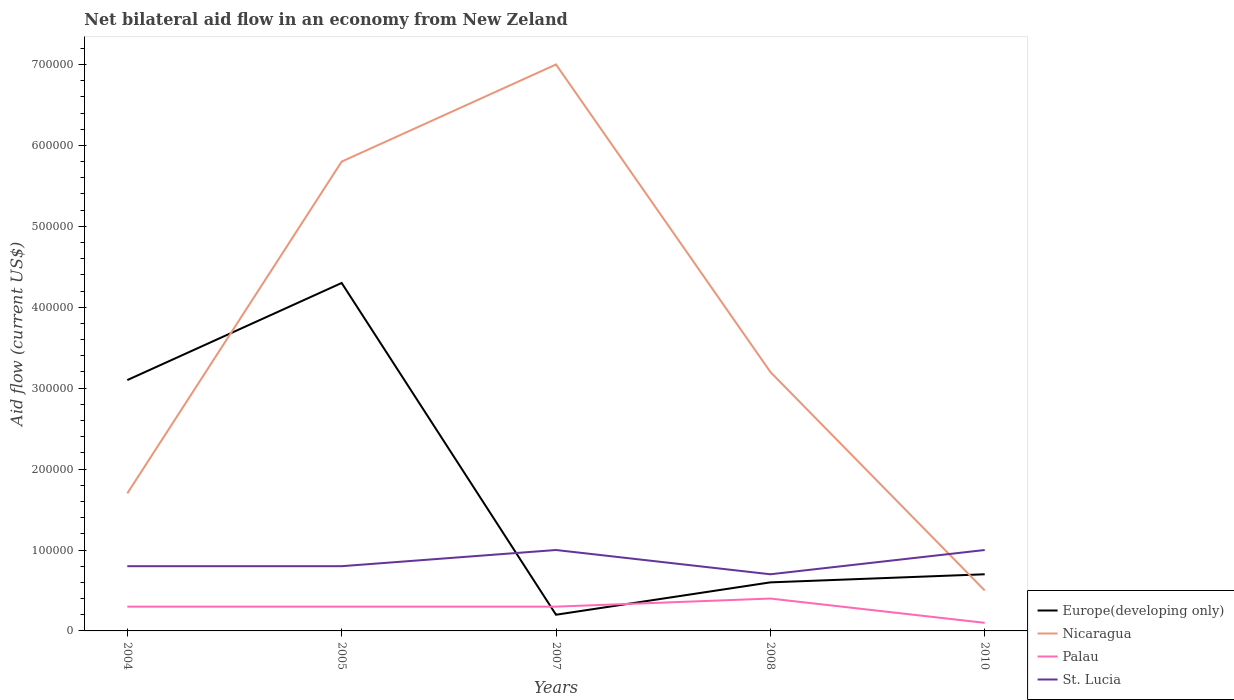How many different coloured lines are there?
Ensure brevity in your answer.  4. Is the number of lines equal to the number of legend labels?
Your answer should be compact. Yes. What is the total net bilateral aid flow in St. Lucia in the graph?
Offer a very short reply. 10000. What is the difference between the highest and the second highest net bilateral aid flow in Europe(developing only)?
Offer a very short reply. 4.10e+05. Is the net bilateral aid flow in Nicaragua strictly greater than the net bilateral aid flow in Europe(developing only) over the years?
Your response must be concise. No. What is the difference between two consecutive major ticks on the Y-axis?
Provide a short and direct response. 1.00e+05. Does the graph contain any zero values?
Your response must be concise. No. How many legend labels are there?
Ensure brevity in your answer.  4. How are the legend labels stacked?
Your answer should be compact. Vertical. What is the title of the graph?
Your response must be concise. Net bilateral aid flow in an economy from New Zeland. Does "Cayman Islands" appear as one of the legend labels in the graph?
Provide a succinct answer. No. What is the label or title of the X-axis?
Ensure brevity in your answer.  Years. What is the label or title of the Y-axis?
Your answer should be compact. Aid flow (current US$). What is the Aid flow (current US$) of Europe(developing only) in 2004?
Ensure brevity in your answer.  3.10e+05. What is the Aid flow (current US$) of Nicaragua in 2004?
Offer a terse response. 1.70e+05. What is the Aid flow (current US$) in Palau in 2004?
Offer a very short reply. 3.00e+04. What is the Aid flow (current US$) in Nicaragua in 2005?
Your answer should be compact. 5.80e+05. What is the Aid flow (current US$) of Europe(developing only) in 2007?
Your answer should be compact. 2.00e+04. What is the Aid flow (current US$) of Nicaragua in 2007?
Ensure brevity in your answer.  7.00e+05. What is the Aid flow (current US$) of Europe(developing only) in 2008?
Your answer should be very brief. 6.00e+04. What is the Aid flow (current US$) of St. Lucia in 2008?
Make the answer very short. 7.00e+04. What is the Aid flow (current US$) of St. Lucia in 2010?
Provide a short and direct response. 1.00e+05. Across all years, what is the maximum Aid flow (current US$) of Europe(developing only)?
Your answer should be very brief. 4.30e+05. Across all years, what is the maximum Aid flow (current US$) in St. Lucia?
Ensure brevity in your answer.  1.00e+05. Across all years, what is the minimum Aid flow (current US$) of Nicaragua?
Offer a very short reply. 5.00e+04. What is the total Aid flow (current US$) of Europe(developing only) in the graph?
Your answer should be compact. 8.90e+05. What is the total Aid flow (current US$) in Nicaragua in the graph?
Offer a terse response. 1.82e+06. What is the total Aid flow (current US$) of Palau in the graph?
Keep it short and to the point. 1.40e+05. What is the difference between the Aid flow (current US$) of Nicaragua in 2004 and that in 2005?
Provide a short and direct response. -4.10e+05. What is the difference between the Aid flow (current US$) of Palau in 2004 and that in 2005?
Offer a terse response. 0. What is the difference between the Aid flow (current US$) of Europe(developing only) in 2004 and that in 2007?
Your answer should be very brief. 2.90e+05. What is the difference between the Aid flow (current US$) of Nicaragua in 2004 and that in 2007?
Ensure brevity in your answer.  -5.30e+05. What is the difference between the Aid flow (current US$) in Palau in 2004 and that in 2008?
Keep it short and to the point. -10000. What is the difference between the Aid flow (current US$) in St. Lucia in 2004 and that in 2008?
Make the answer very short. 10000. What is the difference between the Aid flow (current US$) of Nicaragua in 2004 and that in 2010?
Provide a succinct answer. 1.20e+05. What is the difference between the Aid flow (current US$) of Palau in 2004 and that in 2010?
Your answer should be compact. 2.00e+04. What is the difference between the Aid flow (current US$) in St. Lucia in 2004 and that in 2010?
Provide a succinct answer. -2.00e+04. What is the difference between the Aid flow (current US$) of Europe(developing only) in 2005 and that in 2007?
Make the answer very short. 4.10e+05. What is the difference between the Aid flow (current US$) in Nicaragua in 2005 and that in 2007?
Make the answer very short. -1.20e+05. What is the difference between the Aid flow (current US$) in Palau in 2005 and that in 2007?
Offer a terse response. 0. What is the difference between the Aid flow (current US$) in St. Lucia in 2005 and that in 2007?
Provide a succinct answer. -2.00e+04. What is the difference between the Aid flow (current US$) of Europe(developing only) in 2005 and that in 2008?
Your answer should be very brief. 3.70e+05. What is the difference between the Aid flow (current US$) of Nicaragua in 2005 and that in 2008?
Keep it short and to the point. 2.60e+05. What is the difference between the Aid flow (current US$) in Palau in 2005 and that in 2008?
Your answer should be very brief. -10000. What is the difference between the Aid flow (current US$) in St. Lucia in 2005 and that in 2008?
Provide a short and direct response. 10000. What is the difference between the Aid flow (current US$) in Europe(developing only) in 2005 and that in 2010?
Ensure brevity in your answer.  3.60e+05. What is the difference between the Aid flow (current US$) of Nicaragua in 2005 and that in 2010?
Your answer should be compact. 5.30e+05. What is the difference between the Aid flow (current US$) in Nicaragua in 2007 and that in 2008?
Keep it short and to the point. 3.80e+05. What is the difference between the Aid flow (current US$) of St. Lucia in 2007 and that in 2008?
Ensure brevity in your answer.  3.00e+04. What is the difference between the Aid flow (current US$) in Europe(developing only) in 2007 and that in 2010?
Ensure brevity in your answer.  -5.00e+04. What is the difference between the Aid flow (current US$) in Nicaragua in 2007 and that in 2010?
Your response must be concise. 6.50e+05. What is the difference between the Aid flow (current US$) in Europe(developing only) in 2008 and that in 2010?
Your response must be concise. -10000. What is the difference between the Aid flow (current US$) of Palau in 2008 and that in 2010?
Your answer should be very brief. 3.00e+04. What is the difference between the Aid flow (current US$) of Europe(developing only) in 2004 and the Aid flow (current US$) of Palau in 2005?
Keep it short and to the point. 2.80e+05. What is the difference between the Aid flow (current US$) in Europe(developing only) in 2004 and the Aid flow (current US$) in St. Lucia in 2005?
Offer a terse response. 2.30e+05. What is the difference between the Aid flow (current US$) of Nicaragua in 2004 and the Aid flow (current US$) of Palau in 2005?
Your answer should be compact. 1.40e+05. What is the difference between the Aid flow (current US$) in Nicaragua in 2004 and the Aid flow (current US$) in St. Lucia in 2005?
Offer a very short reply. 9.00e+04. What is the difference between the Aid flow (current US$) in Palau in 2004 and the Aid flow (current US$) in St. Lucia in 2005?
Provide a short and direct response. -5.00e+04. What is the difference between the Aid flow (current US$) in Europe(developing only) in 2004 and the Aid flow (current US$) in Nicaragua in 2007?
Give a very brief answer. -3.90e+05. What is the difference between the Aid flow (current US$) of Europe(developing only) in 2004 and the Aid flow (current US$) of Palau in 2007?
Give a very brief answer. 2.80e+05. What is the difference between the Aid flow (current US$) in Europe(developing only) in 2004 and the Aid flow (current US$) in St. Lucia in 2007?
Your response must be concise. 2.10e+05. What is the difference between the Aid flow (current US$) in Nicaragua in 2004 and the Aid flow (current US$) in Palau in 2007?
Your response must be concise. 1.40e+05. What is the difference between the Aid flow (current US$) in Nicaragua in 2004 and the Aid flow (current US$) in St. Lucia in 2007?
Offer a terse response. 7.00e+04. What is the difference between the Aid flow (current US$) in Europe(developing only) in 2004 and the Aid flow (current US$) in Palau in 2008?
Give a very brief answer. 2.70e+05. What is the difference between the Aid flow (current US$) in Nicaragua in 2004 and the Aid flow (current US$) in Palau in 2008?
Provide a succinct answer. 1.30e+05. What is the difference between the Aid flow (current US$) in Nicaragua in 2004 and the Aid flow (current US$) in St. Lucia in 2008?
Provide a short and direct response. 1.00e+05. What is the difference between the Aid flow (current US$) in Europe(developing only) in 2004 and the Aid flow (current US$) in Palau in 2010?
Your response must be concise. 3.00e+05. What is the difference between the Aid flow (current US$) in Nicaragua in 2004 and the Aid flow (current US$) in Palau in 2010?
Give a very brief answer. 1.60e+05. What is the difference between the Aid flow (current US$) of Palau in 2004 and the Aid flow (current US$) of St. Lucia in 2010?
Offer a very short reply. -7.00e+04. What is the difference between the Aid flow (current US$) in Europe(developing only) in 2005 and the Aid flow (current US$) in Nicaragua in 2007?
Provide a succinct answer. -2.70e+05. What is the difference between the Aid flow (current US$) of Europe(developing only) in 2005 and the Aid flow (current US$) of Palau in 2007?
Provide a succinct answer. 4.00e+05. What is the difference between the Aid flow (current US$) in Europe(developing only) in 2005 and the Aid flow (current US$) in St. Lucia in 2007?
Provide a short and direct response. 3.30e+05. What is the difference between the Aid flow (current US$) in Nicaragua in 2005 and the Aid flow (current US$) in Palau in 2007?
Give a very brief answer. 5.50e+05. What is the difference between the Aid flow (current US$) in Europe(developing only) in 2005 and the Aid flow (current US$) in St. Lucia in 2008?
Provide a succinct answer. 3.60e+05. What is the difference between the Aid flow (current US$) in Nicaragua in 2005 and the Aid flow (current US$) in Palau in 2008?
Your response must be concise. 5.40e+05. What is the difference between the Aid flow (current US$) of Nicaragua in 2005 and the Aid flow (current US$) of St. Lucia in 2008?
Your response must be concise. 5.10e+05. What is the difference between the Aid flow (current US$) in Europe(developing only) in 2005 and the Aid flow (current US$) in Nicaragua in 2010?
Ensure brevity in your answer.  3.80e+05. What is the difference between the Aid flow (current US$) of Nicaragua in 2005 and the Aid flow (current US$) of Palau in 2010?
Keep it short and to the point. 5.70e+05. What is the difference between the Aid flow (current US$) of Palau in 2005 and the Aid flow (current US$) of St. Lucia in 2010?
Ensure brevity in your answer.  -7.00e+04. What is the difference between the Aid flow (current US$) in Europe(developing only) in 2007 and the Aid flow (current US$) in St. Lucia in 2008?
Give a very brief answer. -5.00e+04. What is the difference between the Aid flow (current US$) in Nicaragua in 2007 and the Aid flow (current US$) in St. Lucia in 2008?
Provide a succinct answer. 6.30e+05. What is the difference between the Aid flow (current US$) in Palau in 2007 and the Aid flow (current US$) in St. Lucia in 2008?
Your response must be concise. -4.00e+04. What is the difference between the Aid flow (current US$) in Nicaragua in 2007 and the Aid flow (current US$) in Palau in 2010?
Make the answer very short. 6.90e+05. What is the difference between the Aid flow (current US$) of Palau in 2007 and the Aid flow (current US$) of St. Lucia in 2010?
Offer a terse response. -7.00e+04. What is the difference between the Aid flow (current US$) of Europe(developing only) in 2008 and the Aid flow (current US$) of Nicaragua in 2010?
Your answer should be compact. 10000. What is the difference between the Aid flow (current US$) in Nicaragua in 2008 and the Aid flow (current US$) in Palau in 2010?
Give a very brief answer. 3.10e+05. What is the difference between the Aid flow (current US$) of Nicaragua in 2008 and the Aid flow (current US$) of St. Lucia in 2010?
Offer a very short reply. 2.20e+05. What is the average Aid flow (current US$) of Europe(developing only) per year?
Keep it short and to the point. 1.78e+05. What is the average Aid flow (current US$) in Nicaragua per year?
Keep it short and to the point. 3.64e+05. What is the average Aid flow (current US$) of Palau per year?
Provide a succinct answer. 2.80e+04. What is the average Aid flow (current US$) in St. Lucia per year?
Your answer should be compact. 8.60e+04. In the year 2004, what is the difference between the Aid flow (current US$) in Europe(developing only) and Aid flow (current US$) in Nicaragua?
Provide a succinct answer. 1.40e+05. In the year 2004, what is the difference between the Aid flow (current US$) in Nicaragua and Aid flow (current US$) in St. Lucia?
Offer a terse response. 9.00e+04. In the year 2004, what is the difference between the Aid flow (current US$) in Palau and Aid flow (current US$) in St. Lucia?
Offer a terse response. -5.00e+04. In the year 2005, what is the difference between the Aid flow (current US$) of Europe(developing only) and Aid flow (current US$) of Palau?
Provide a succinct answer. 4.00e+05. In the year 2005, what is the difference between the Aid flow (current US$) in Nicaragua and Aid flow (current US$) in Palau?
Your answer should be very brief. 5.50e+05. In the year 2005, what is the difference between the Aid flow (current US$) in Nicaragua and Aid flow (current US$) in St. Lucia?
Your answer should be compact. 5.00e+05. In the year 2005, what is the difference between the Aid flow (current US$) of Palau and Aid flow (current US$) of St. Lucia?
Your response must be concise. -5.00e+04. In the year 2007, what is the difference between the Aid flow (current US$) of Europe(developing only) and Aid flow (current US$) of Nicaragua?
Provide a short and direct response. -6.80e+05. In the year 2007, what is the difference between the Aid flow (current US$) in Europe(developing only) and Aid flow (current US$) in Palau?
Ensure brevity in your answer.  -10000. In the year 2007, what is the difference between the Aid flow (current US$) in Europe(developing only) and Aid flow (current US$) in St. Lucia?
Ensure brevity in your answer.  -8.00e+04. In the year 2007, what is the difference between the Aid flow (current US$) in Nicaragua and Aid flow (current US$) in Palau?
Make the answer very short. 6.70e+05. In the year 2007, what is the difference between the Aid flow (current US$) of Nicaragua and Aid flow (current US$) of St. Lucia?
Give a very brief answer. 6.00e+05. In the year 2008, what is the difference between the Aid flow (current US$) of Europe(developing only) and Aid flow (current US$) of Nicaragua?
Ensure brevity in your answer.  -2.60e+05. In the year 2008, what is the difference between the Aid flow (current US$) of Europe(developing only) and Aid flow (current US$) of Palau?
Your response must be concise. 2.00e+04. In the year 2008, what is the difference between the Aid flow (current US$) in Europe(developing only) and Aid flow (current US$) in St. Lucia?
Provide a short and direct response. -10000. In the year 2008, what is the difference between the Aid flow (current US$) in Palau and Aid flow (current US$) in St. Lucia?
Offer a very short reply. -3.00e+04. In the year 2010, what is the difference between the Aid flow (current US$) of Europe(developing only) and Aid flow (current US$) of St. Lucia?
Keep it short and to the point. -3.00e+04. In the year 2010, what is the difference between the Aid flow (current US$) in Nicaragua and Aid flow (current US$) in St. Lucia?
Your response must be concise. -5.00e+04. What is the ratio of the Aid flow (current US$) in Europe(developing only) in 2004 to that in 2005?
Provide a short and direct response. 0.72. What is the ratio of the Aid flow (current US$) of Nicaragua in 2004 to that in 2005?
Provide a short and direct response. 0.29. What is the ratio of the Aid flow (current US$) of St. Lucia in 2004 to that in 2005?
Offer a very short reply. 1. What is the ratio of the Aid flow (current US$) in Nicaragua in 2004 to that in 2007?
Keep it short and to the point. 0.24. What is the ratio of the Aid flow (current US$) in Europe(developing only) in 2004 to that in 2008?
Ensure brevity in your answer.  5.17. What is the ratio of the Aid flow (current US$) in Nicaragua in 2004 to that in 2008?
Offer a very short reply. 0.53. What is the ratio of the Aid flow (current US$) of St. Lucia in 2004 to that in 2008?
Your response must be concise. 1.14. What is the ratio of the Aid flow (current US$) of Europe(developing only) in 2004 to that in 2010?
Keep it short and to the point. 4.43. What is the ratio of the Aid flow (current US$) of Nicaragua in 2004 to that in 2010?
Your answer should be very brief. 3.4. What is the ratio of the Aid flow (current US$) of Palau in 2004 to that in 2010?
Your answer should be very brief. 3. What is the ratio of the Aid flow (current US$) of Europe(developing only) in 2005 to that in 2007?
Ensure brevity in your answer.  21.5. What is the ratio of the Aid flow (current US$) of Nicaragua in 2005 to that in 2007?
Offer a terse response. 0.83. What is the ratio of the Aid flow (current US$) in Palau in 2005 to that in 2007?
Your answer should be compact. 1. What is the ratio of the Aid flow (current US$) in Europe(developing only) in 2005 to that in 2008?
Give a very brief answer. 7.17. What is the ratio of the Aid flow (current US$) of Nicaragua in 2005 to that in 2008?
Your answer should be compact. 1.81. What is the ratio of the Aid flow (current US$) in Europe(developing only) in 2005 to that in 2010?
Your response must be concise. 6.14. What is the ratio of the Aid flow (current US$) of Nicaragua in 2007 to that in 2008?
Make the answer very short. 2.19. What is the ratio of the Aid flow (current US$) in Palau in 2007 to that in 2008?
Offer a terse response. 0.75. What is the ratio of the Aid flow (current US$) of St. Lucia in 2007 to that in 2008?
Offer a very short reply. 1.43. What is the ratio of the Aid flow (current US$) of Europe(developing only) in 2007 to that in 2010?
Make the answer very short. 0.29. What is the ratio of the Aid flow (current US$) of Nicaragua in 2007 to that in 2010?
Your response must be concise. 14. What is the ratio of the Aid flow (current US$) in St. Lucia in 2007 to that in 2010?
Your answer should be very brief. 1. What is the ratio of the Aid flow (current US$) of Nicaragua in 2008 to that in 2010?
Provide a succinct answer. 6.4. What is the ratio of the Aid flow (current US$) in Palau in 2008 to that in 2010?
Ensure brevity in your answer.  4. What is the difference between the highest and the second highest Aid flow (current US$) in St. Lucia?
Make the answer very short. 0. What is the difference between the highest and the lowest Aid flow (current US$) in Nicaragua?
Your answer should be compact. 6.50e+05. What is the difference between the highest and the lowest Aid flow (current US$) of Palau?
Your response must be concise. 3.00e+04. 